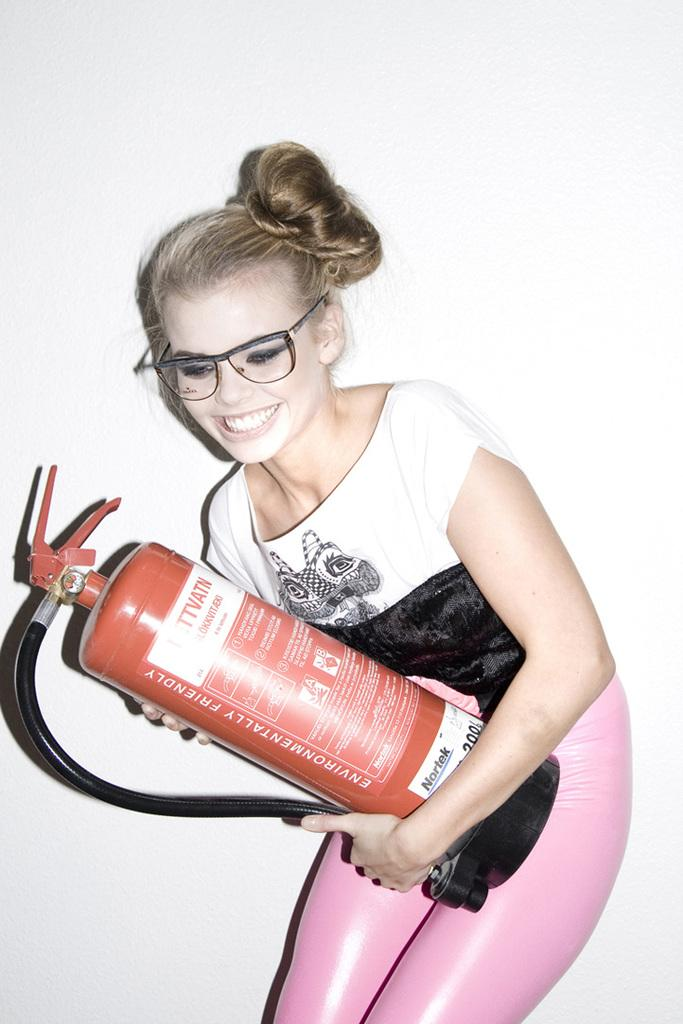Who is present in the image? There is a woman in the image. What is the woman wearing? The woman is wearing spectacles. What is the woman holding in the image? The woman is holding a cylinder. What can be seen in the background of the image? There is a wall in the background of the image. What type of agreement is being discussed by the woman in the image? There is no indication in the image that the woman is discussing any agreement, as the focus is on her appearance and the object she is holding. 